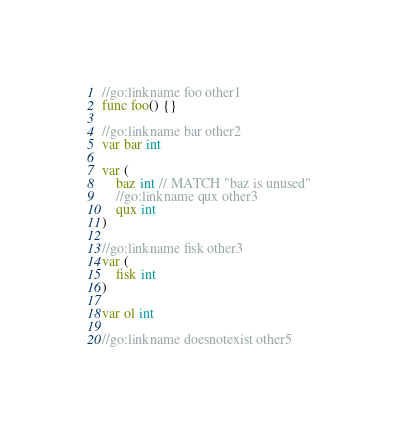<code> <loc_0><loc_0><loc_500><loc_500><_Go_>
//go:linkname foo other1
func foo() {}

//go:linkname bar other2
var bar int

var (
	baz int // MATCH "baz is unused"
	//go:linkname qux other3
	qux int
)

//go:linkname fisk other3
var (
	fisk int
)

var ol int

//go:linkname doesnotexist other5
</code> 